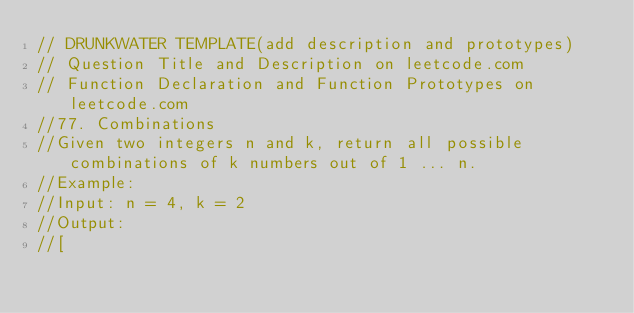<code> <loc_0><loc_0><loc_500><loc_500><_Swift_>// DRUNKWATER TEMPLATE(add description and prototypes)
// Question Title and Description on leetcode.com
// Function Declaration and Function Prototypes on leetcode.com
//77. Combinations
//Given two integers n and k, return all possible combinations of k numbers out of 1 ... n.
//Example:
//Input: n = 4, k = 2
//Output:
//[</code> 